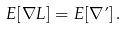<formula> <loc_0><loc_0><loc_500><loc_500>E [ \nabla L ] = E [ \nabla \varphi ] \, .</formula> 